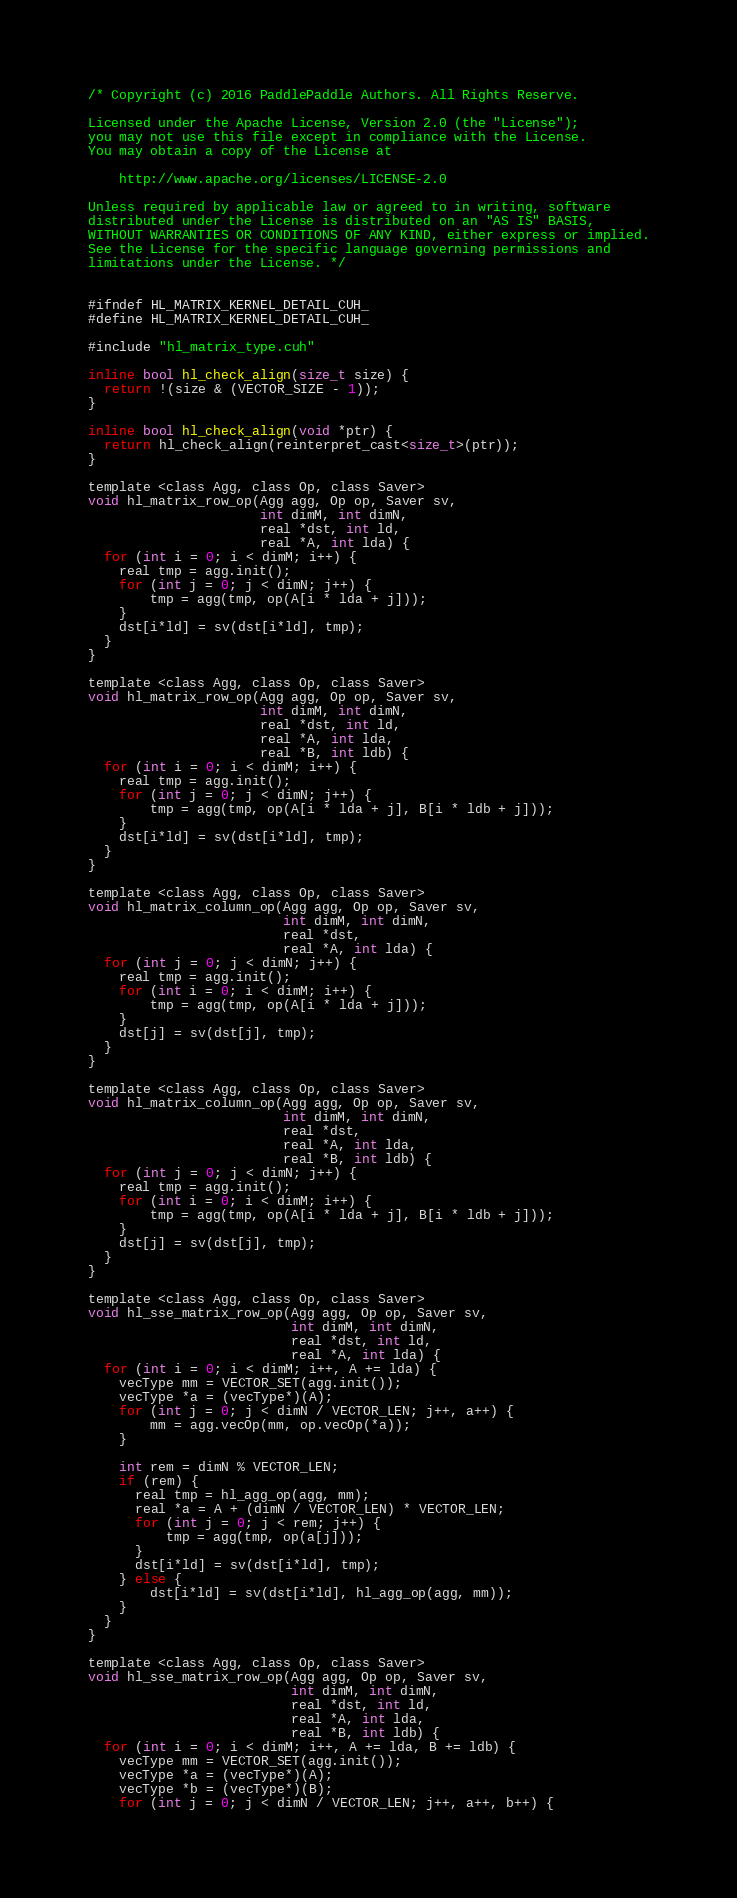Convert code to text. <code><loc_0><loc_0><loc_500><loc_500><_Cuda_>/* Copyright (c) 2016 PaddlePaddle Authors. All Rights Reserve.

Licensed under the Apache License, Version 2.0 (the "License");
you may not use this file except in compliance with the License.
You may obtain a copy of the License at

    http://www.apache.org/licenses/LICENSE-2.0

Unless required by applicable law or agreed to in writing, software
distributed under the License is distributed on an "AS IS" BASIS,
WITHOUT WARRANTIES OR CONDITIONS OF ANY KIND, either express or implied.
See the License for the specific language governing permissions and
limitations under the License. */


#ifndef HL_MATRIX_KERNEL_DETAIL_CUH_
#define HL_MATRIX_KERNEL_DETAIL_CUH_

#include "hl_matrix_type.cuh"

inline bool hl_check_align(size_t size) {
  return !(size & (VECTOR_SIZE - 1));
}

inline bool hl_check_align(void *ptr) {
  return hl_check_align(reinterpret_cast<size_t>(ptr));
}

template <class Agg, class Op, class Saver>
void hl_matrix_row_op(Agg agg, Op op, Saver sv,
                      int dimM, int dimN,
                      real *dst, int ld,
                      real *A, int lda) {
  for (int i = 0; i < dimM; i++) {
    real tmp = agg.init();
    for (int j = 0; j < dimN; j++) {
        tmp = agg(tmp, op(A[i * lda + j]));
    }
    dst[i*ld] = sv(dst[i*ld], tmp);
  }
}

template <class Agg, class Op, class Saver>
void hl_matrix_row_op(Agg agg, Op op, Saver sv,
                      int dimM, int dimN,
                      real *dst, int ld,
                      real *A, int lda,
                      real *B, int ldb) {
  for (int i = 0; i < dimM; i++) {
    real tmp = agg.init();
    for (int j = 0; j < dimN; j++) {
        tmp = agg(tmp, op(A[i * lda + j], B[i * ldb + j]));
    }
    dst[i*ld] = sv(dst[i*ld], tmp);
  }
}

template <class Agg, class Op, class Saver>
void hl_matrix_column_op(Agg agg, Op op, Saver sv,
                         int dimM, int dimN,
                         real *dst,
                         real *A, int lda) {
  for (int j = 0; j < dimN; j++) {
    real tmp = agg.init();
    for (int i = 0; i < dimM; i++) {
        tmp = agg(tmp, op(A[i * lda + j]));
    }
    dst[j] = sv(dst[j], tmp);
  }
}

template <class Agg, class Op, class Saver>
void hl_matrix_column_op(Agg agg, Op op, Saver sv,
                         int dimM, int dimN,
                         real *dst,
                         real *A, int lda,
                         real *B, int ldb) {
  for (int j = 0; j < dimN; j++) {
    real tmp = agg.init();
    for (int i = 0; i < dimM; i++) {
        tmp = agg(tmp, op(A[i * lda + j], B[i * ldb + j]));
    }
    dst[j] = sv(dst[j], tmp);
  }
}

template <class Agg, class Op, class Saver>
void hl_sse_matrix_row_op(Agg agg, Op op, Saver sv,
                          int dimM, int dimN,
                          real *dst, int ld,
                          real *A, int lda) {
  for (int i = 0; i < dimM; i++, A += lda) {
    vecType mm = VECTOR_SET(agg.init());
    vecType *a = (vecType*)(A);
    for (int j = 0; j < dimN / VECTOR_LEN; j++, a++) {
        mm = agg.vecOp(mm, op.vecOp(*a));
    }

    int rem = dimN % VECTOR_LEN;
    if (rem) {
      real tmp = hl_agg_op(agg, mm);
      real *a = A + (dimN / VECTOR_LEN) * VECTOR_LEN;
      for (int j = 0; j < rem; j++) {
          tmp = agg(tmp, op(a[j]));
      }
      dst[i*ld] = sv(dst[i*ld], tmp);
    } else {
        dst[i*ld] = sv(dst[i*ld], hl_agg_op(agg, mm));
    }
  }
}

template <class Agg, class Op, class Saver>
void hl_sse_matrix_row_op(Agg agg, Op op, Saver sv,
                          int dimM, int dimN,
                          real *dst, int ld,
                          real *A, int lda,
                          real *B, int ldb) {
  for (int i = 0; i < dimM; i++, A += lda, B += ldb) {
    vecType mm = VECTOR_SET(agg.init());
    vecType *a = (vecType*)(A);
    vecType *b = (vecType*)(B);
    for (int j = 0; j < dimN / VECTOR_LEN; j++, a++, b++) {</code> 